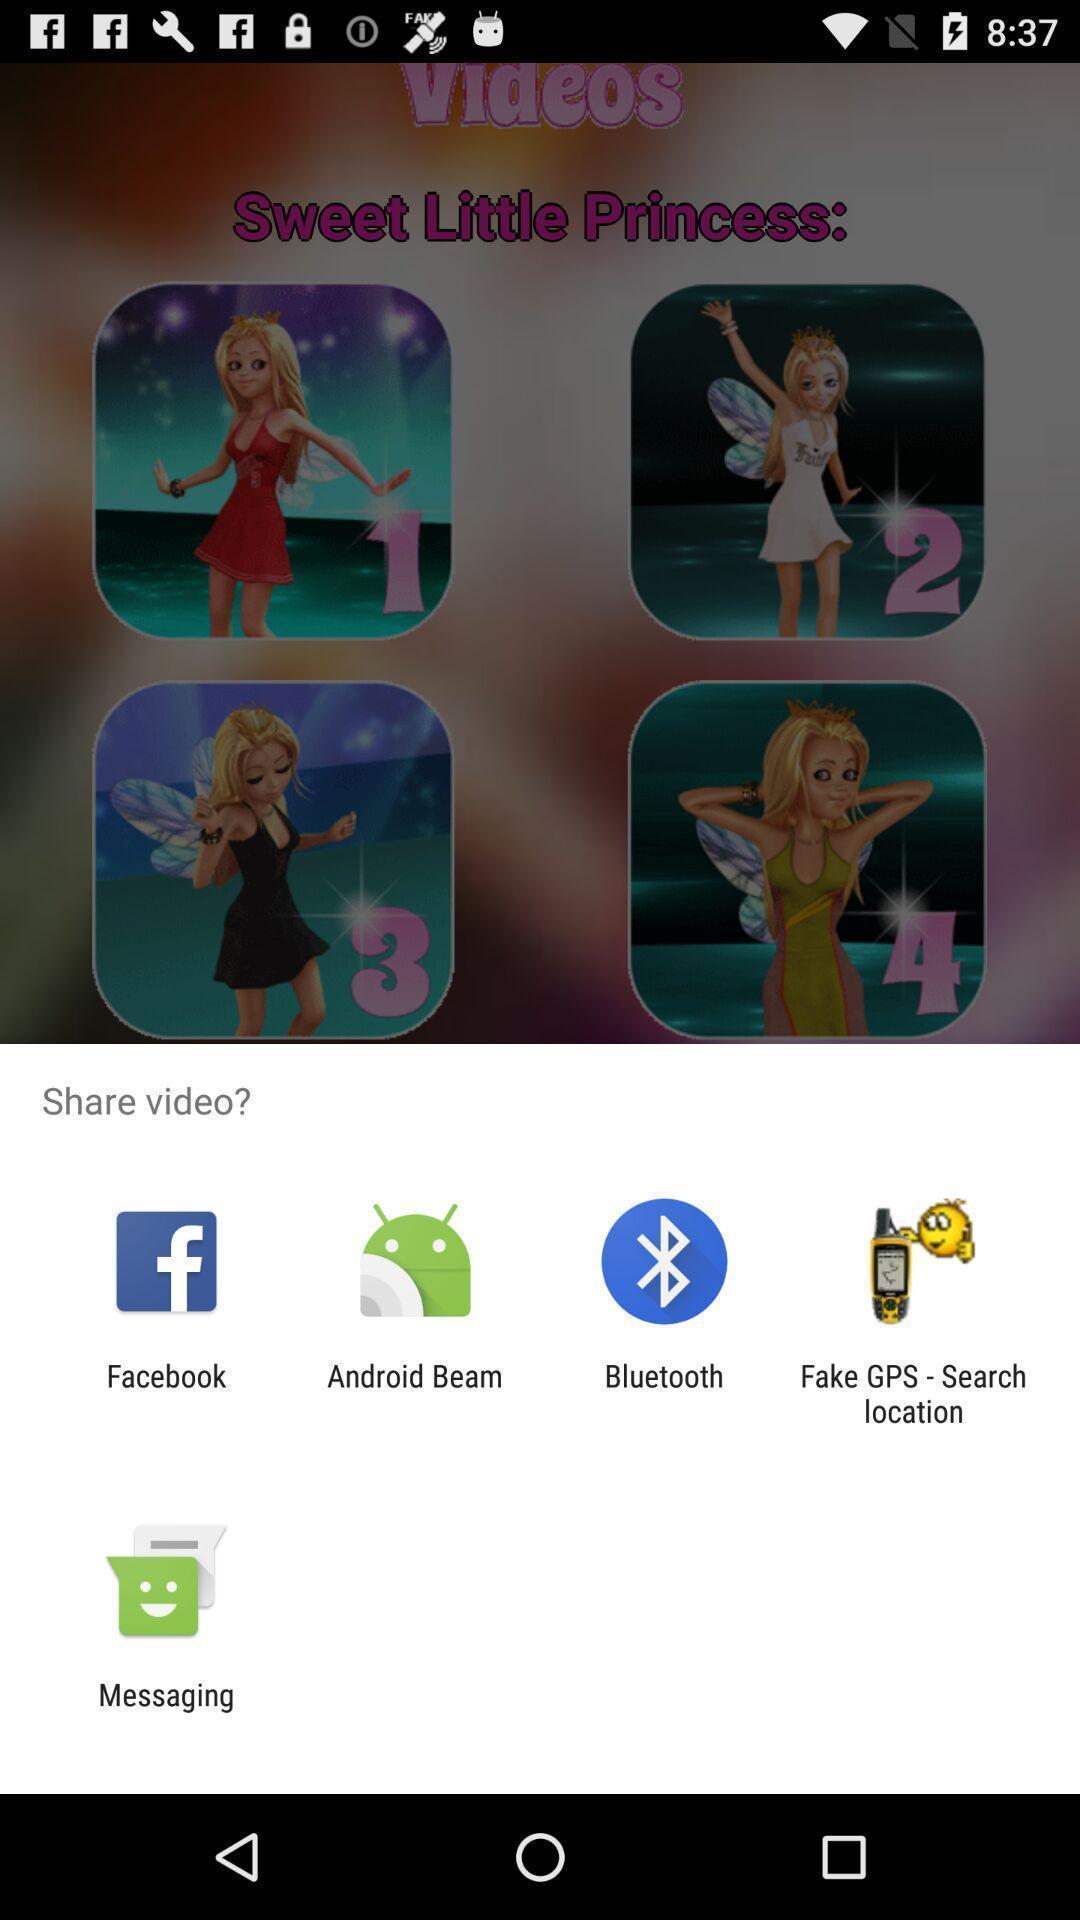Describe the visual elements of this screenshot. Push up page showing app preference to share. 